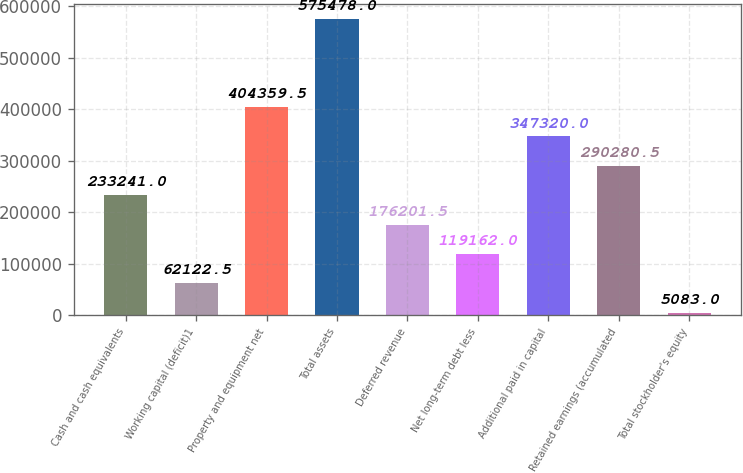Convert chart. <chart><loc_0><loc_0><loc_500><loc_500><bar_chart><fcel>Cash and cash equivalents<fcel>Working capital (deficit)1<fcel>Property and equipment net<fcel>Total assets<fcel>Deferred revenue<fcel>Net long-term debt less<fcel>Additional paid in capital<fcel>Retained earnings (accumulated<fcel>Total stockholder's equity<nl><fcel>233241<fcel>62122.5<fcel>404360<fcel>575478<fcel>176202<fcel>119162<fcel>347320<fcel>290280<fcel>5083<nl></chart> 